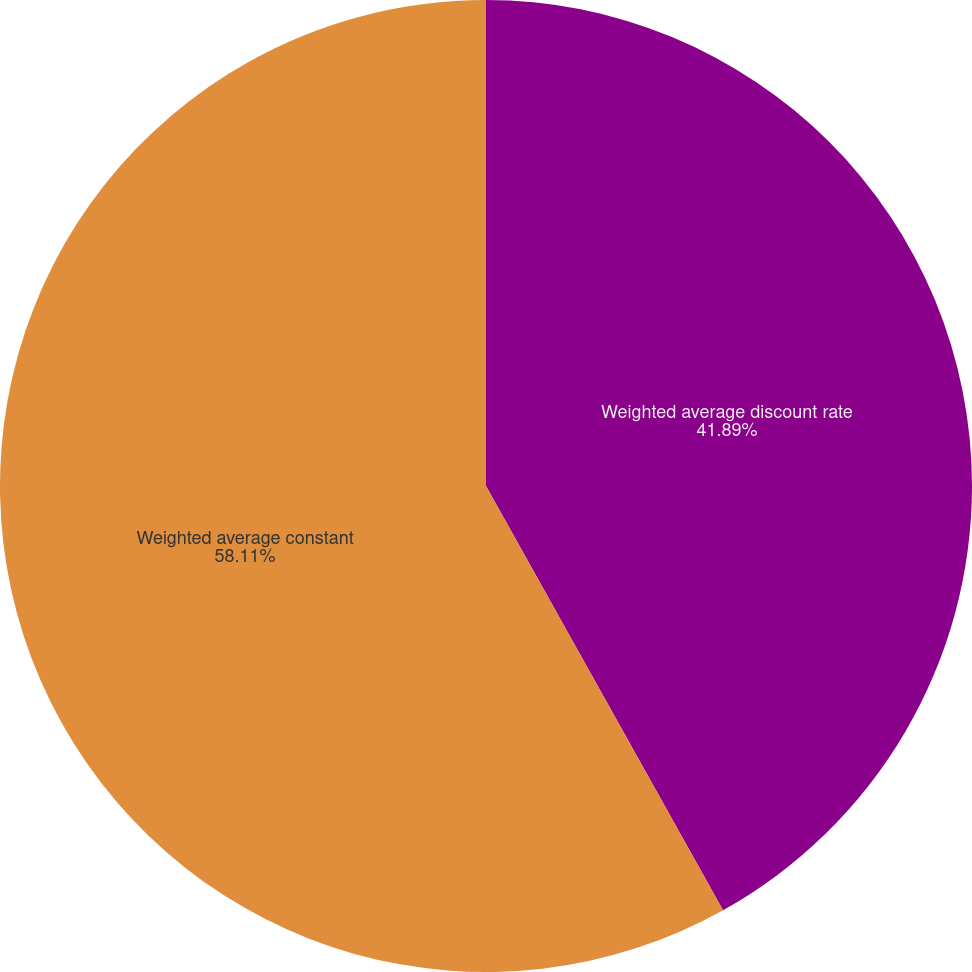Convert chart to OTSL. <chart><loc_0><loc_0><loc_500><loc_500><pie_chart><fcel>Weighted average discount rate<fcel>Weighted average constant<nl><fcel>41.89%<fcel>58.11%<nl></chart> 